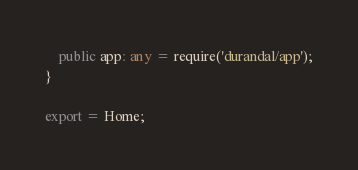<code> <loc_0><loc_0><loc_500><loc_500><_TypeScript_>    public app: any = require('durandal/app');
}

export = Home;
</code> 